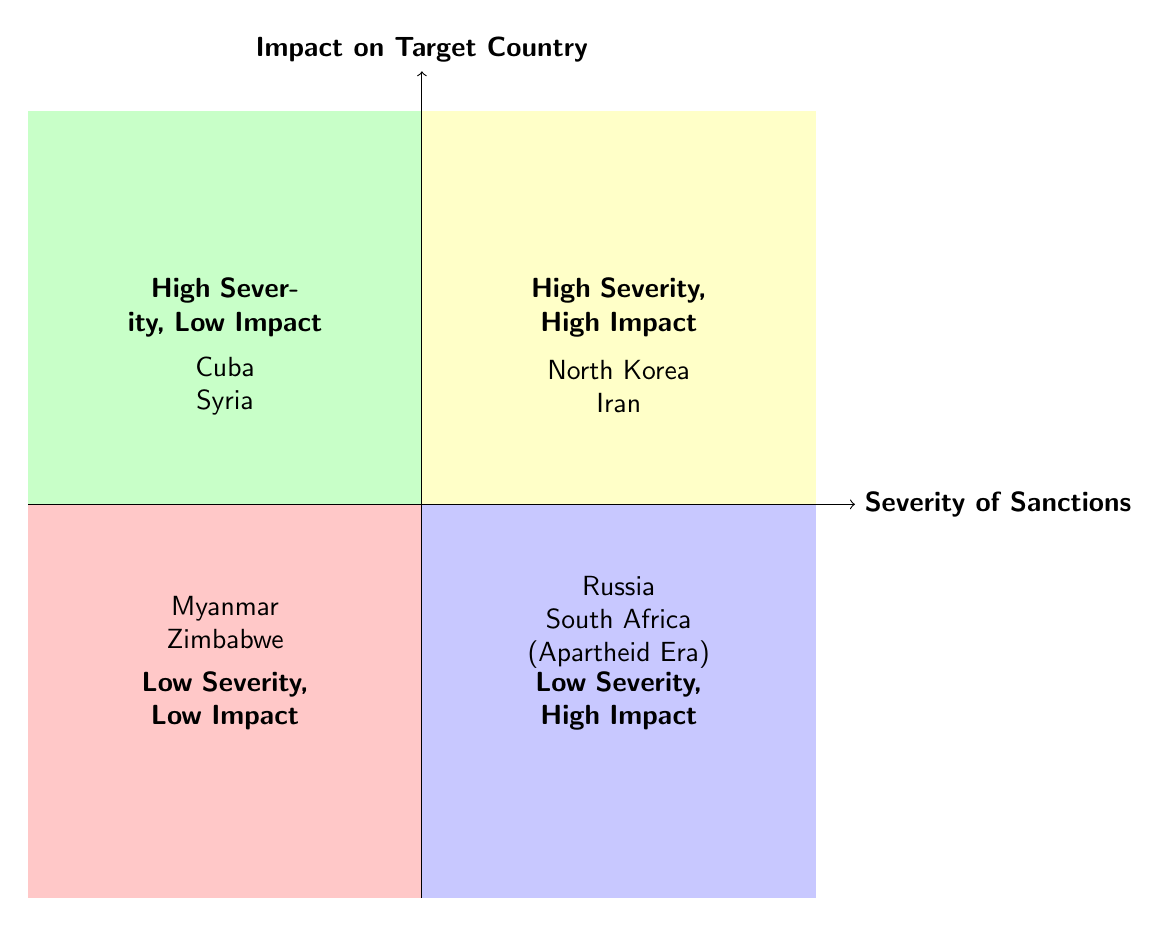What countries are in the "High Severity, High Impact" quadrant? The "High Severity, High Impact" quadrant contains examples of countries that face both high severity of sanctions and significant impacts. According to the diagram, these countries are North Korea and Iran.
Answer: North Korea, Iran What types of sanctions does Syria face? In the diagram, Syria is listed under the "High Severity, Low Impact" quadrant, and the types of sanctions it faces are Economic and Military.
Answer: Economic, Military Which quadrant includes Myanmar? The diagram places Myanmar in the "Low Severity, Low Impact" quadrant, indicating that the impact of sanctions is low despite having some severity.
Answer: Low Severity, Low Impact How many countries are categorized as "Low Severity, High Impact"? The "Low Severity, High Impact" quadrant shows two countries, which are Russia and South Africa (Apartheid Era). Thus, the total number of countries in this category is two.
Answer: 2 Which sanctioning entities imposed sanctions on North Korea? North Korea is listed in the "High Severity, High Impact" quadrant and is subjected to sanctions imposed by the United Nations, the United States, and the European Union.
Answer: United Nations, United States, European Union Which quadrant contains Cuba and what does this imply? Cuba is found in the "High Severity, Low Impact" quadrant, which suggests that while the sanctions against Cuba may be severe, they do not lead to a significant impact on the country.
Answer: High Severity, Low Impact What is the relationship between the severity of sanctions and the impact on Zimbabwe? According to the diagram, Zimbabwe is categorized under "Low Severity, Low Impact," indicating that the sanctions are not severe and have negligible effects on the country.
Answer: Low Severity, Low Impact Which countries have Economic sanctions listed under "Low Severity, High Impact"? The "Low Severity, High Impact" quadrant has only one example listed with Economic sanctions, which is Russia, indicating its substantial impact despite the lower severity of sanctions.
Answer: Russia 